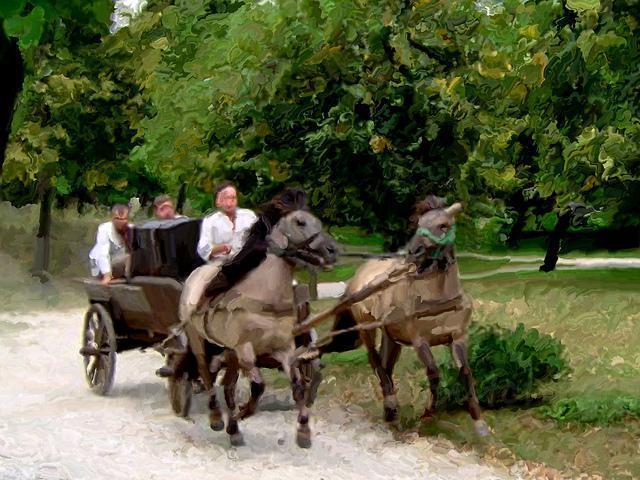How many horse(s) are pulling the carriage?
Give a very brief answer. 2. How many people are in the carriage?
Give a very brief answer. 3. How many horses are present?
Give a very brief answer. 2. How many men are in the trailer?
Give a very brief answer. 3. How many horses are there?
Give a very brief answer. 2. How many people are in the photo?
Give a very brief answer. 2. How many of the motorcycles are blue?
Give a very brief answer. 0. 